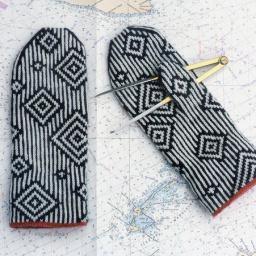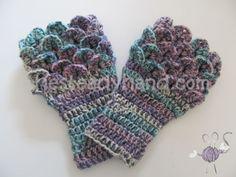The first image is the image on the left, the second image is the image on the right. Given the left and right images, does the statement "At least one pair of mittens features a pointed, triangular shaped top, rather than a rounded one." hold true? Answer yes or no. No. The first image is the image on the left, the second image is the image on the right. Assess this claim about the two images: "One image had a clear,wooden background surface.". Correct or not? Answer yes or no. No. 